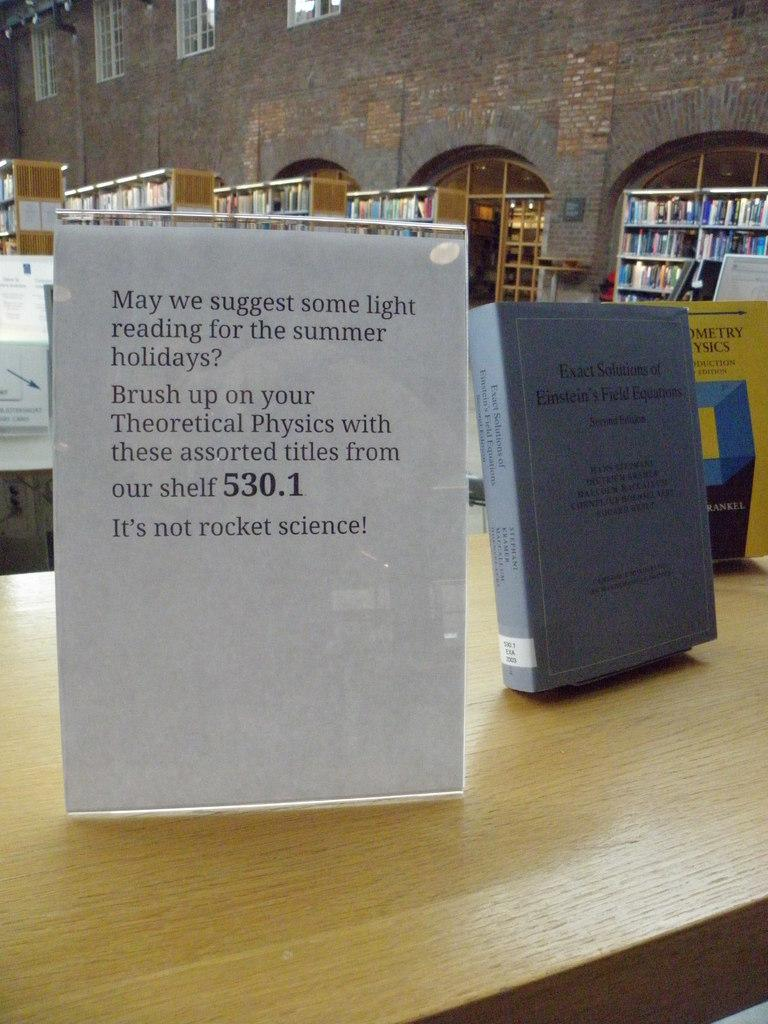<image>
Write a terse but informative summary of the picture. White sign that has the numbers 530.1 on it. 